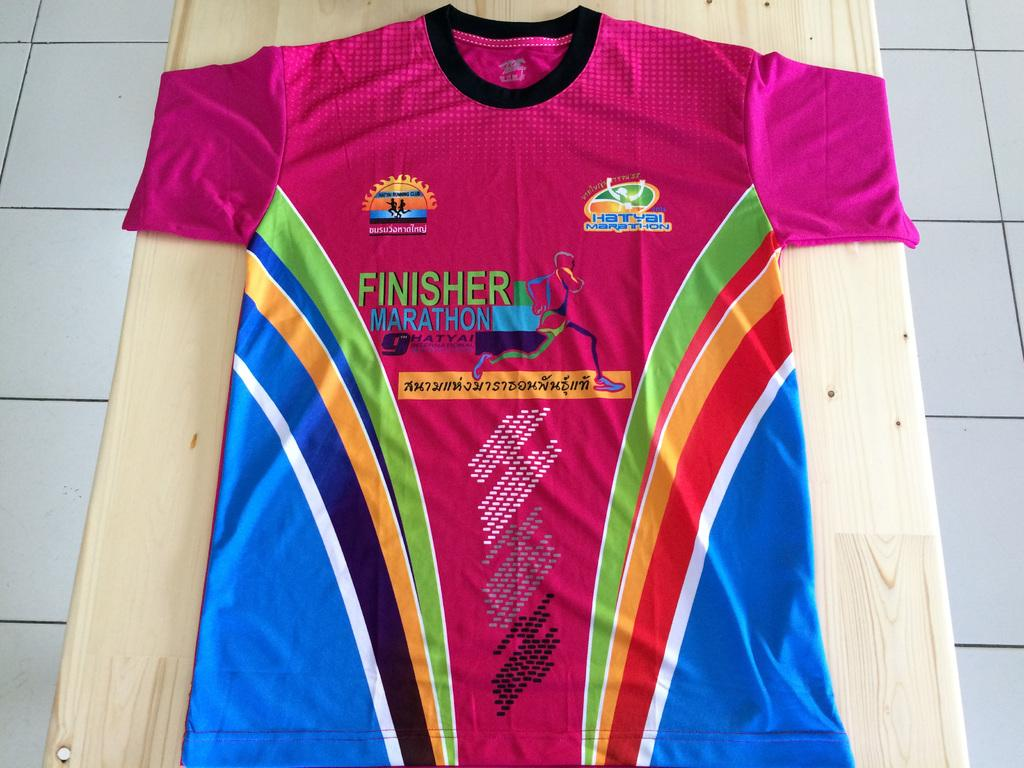<image>
Write a terse but informative summary of the picture. Pink shirt that says Finisher Marathon on a wooden table. 